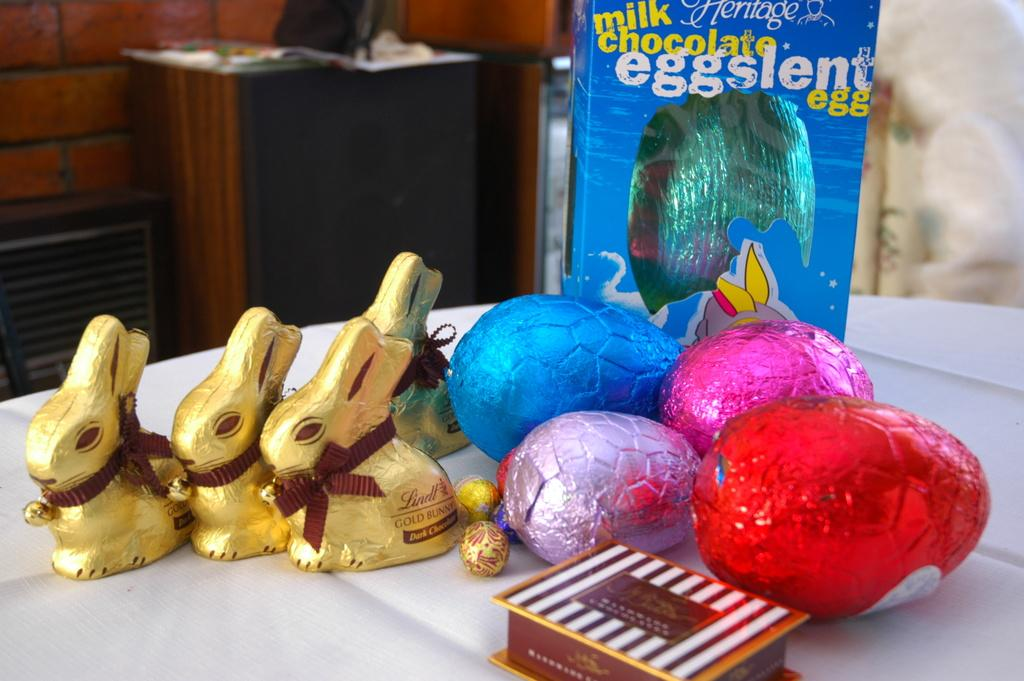What is the main piece of furniture in the image? There is a table in the image. What items are on the table? There are toys and colorful balls on the table. Is there any storage visible in the image? Yes, there is a box beside the table. Are there any other tables in the image? Yes, there is another table in the image. What can be seen in the background of the image? There is a wall visible in the image. How many guns are visible on the table in the image? There are no guns present in the image; it features toys and colorful balls on the table. What type of horses can be seen interacting with the toys on the table? There are no horses present in the image; only toys and colorful balls are visible on the table. 